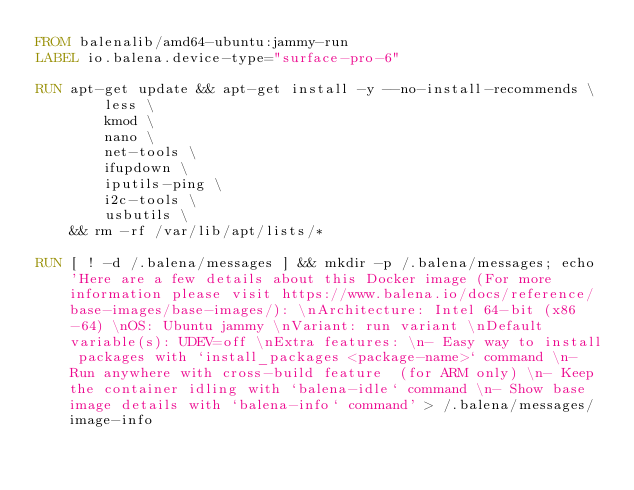Convert code to text. <code><loc_0><loc_0><loc_500><loc_500><_Dockerfile_>FROM balenalib/amd64-ubuntu:jammy-run
LABEL io.balena.device-type="surface-pro-6"

RUN apt-get update && apt-get install -y --no-install-recommends \
		less \
		kmod \
		nano \
		net-tools \
		ifupdown \
		iputils-ping \
		i2c-tools \
		usbutils \
	&& rm -rf /var/lib/apt/lists/*

RUN [ ! -d /.balena/messages ] && mkdir -p /.balena/messages; echo 'Here are a few details about this Docker image (For more information please visit https://www.balena.io/docs/reference/base-images/base-images/): \nArchitecture: Intel 64-bit (x86-64) \nOS: Ubuntu jammy \nVariant: run variant \nDefault variable(s): UDEV=off \nExtra features: \n- Easy way to install packages with `install_packages <package-name>` command \n- Run anywhere with cross-build feature  (for ARM only) \n- Keep the container idling with `balena-idle` command \n- Show base image details with `balena-info` command' > /.balena/messages/image-info</code> 